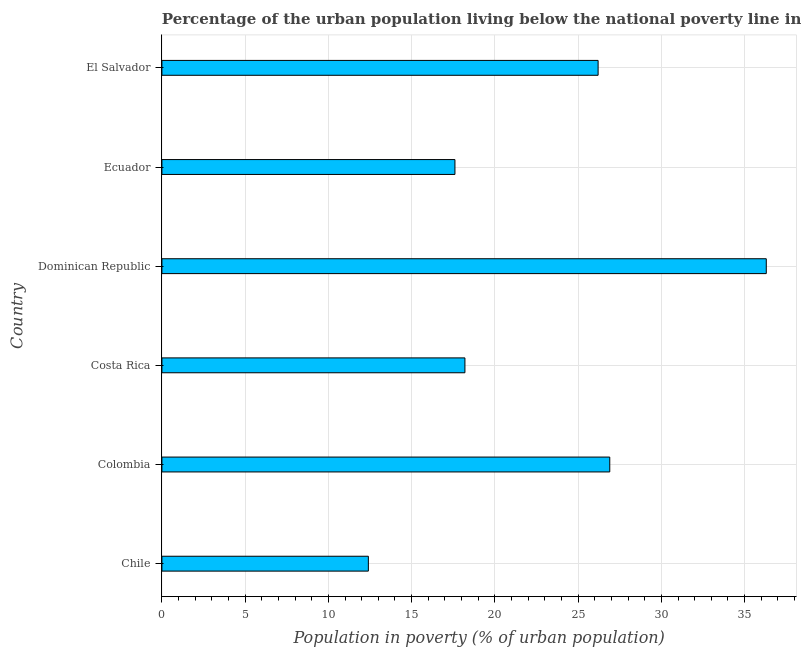What is the title of the graph?
Provide a succinct answer. Percentage of the urban population living below the national poverty line in 2013. What is the label or title of the X-axis?
Provide a short and direct response. Population in poverty (% of urban population). What is the label or title of the Y-axis?
Make the answer very short. Country. What is the percentage of urban population living below poverty line in Ecuador?
Offer a very short reply. 17.6. Across all countries, what is the maximum percentage of urban population living below poverty line?
Ensure brevity in your answer.  36.3. In which country was the percentage of urban population living below poverty line maximum?
Your answer should be compact. Dominican Republic. What is the sum of the percentage of urban population living below poverty line?
Your answer should be compact. 137.6. What is the difference between the percentage of urban population living below poverty line in Ecuador and El Salvador?
Your answer should be very brief. -8.6. What is the average percentage of urban population living below poverty line per country?
Your response must be concise. 22.93. What is the median percentage of urban population living below poverty line?
Your response must be concise. 22.2. What is the ratio of the percentage of urban population living below poverty line in Chile to that in El Salvador?
Ensure brevity in your answer.  0.47. Is the sum of the percentage of urban population living below poverty line in Dominican Republic and El Salvador greater than the maximum percentage of urban population living below poverty line across all countries?
Offer a terse response. Yes. What is the difference between the highest and the lowest percentage of urban population living below poverty line?
Your response must be concise. 23.9. Are all the bars in the graph horizontal?
Your response must be concise. Yes. How many countries are there in the graph?
Provide a succinct answer. 6. Are the values on the major ticks of X-axis written in scientific E-notation?
Keep it short and to the point. No. What is the Population in poverty (% of urban population) of Colombia?
Offer a terse response. 26.9. What is the Population in poverty (% of urban population) of Costa Rica?
Your answer should be very brief. 18.2. What is the Population in poverty (% of urban population) of Dominican Republic?
Provide a succinct answer. 36.3. What is the Population in poverty (% of urban population) of El Salvador?
Keep it short and to the point. 26.2. What is the difference between the Population in poverty (% of urban population) in Chile and Colombia?
Provide a succinct answer. -14.5. What is the difference between the Population in poverty (% of urban population) in Chile and Costa Rica?
Your answer should be very brief. -5.8. What is the difference between the Population in poverty (% of urban population) in Chile and Dominican Republic?
Offer a very short reply. -23.9. What is the difference between the Population in poverty (% of urban population) in Chile and El Salvador?
Give a very brief answer. -13.8. What is the difference between the Population in poverty (% of urban population) in Colombia and El Salvador?
Make the answer very short. 0.7. What is the difference between the Population in poverty (% of urban population) in Costa Rica and Dominican Republic?
Offer a terse response. -18.1. What is the difference between the Population in poverty (% of urban population) in Costa Rica and El Salvador?
Ensure brevity in your answer.  -8. What is the difference between the Population in poverty (% of urban population) in Dominican Republic and El Salvador?
Ensure brevity in your answer.  10.1. What is the difference between the Population in poverty (% of urban population) in Ecuador and El Salvador?
Provide a short and direct response. -8.6. What is the ratio of the Population in poverty (% of urban population) in Chile to that in Colombia?
Give a very brief answer. 0.46. What is the ratio of the Population in poverty (% of urban population) in Chile to that in Costa Rica?
Your response must be concise. 0.68. What is the ratio of the Population in poverty (% of urban population) in Chile to that in Dominican Republic?
Your answer should be compact. 0.34. What is the ratio of the Population in poverty (% of urban population) in Chile to that in Ecuador?
Provide a succinct answer. 0.7. What is the ratio of the Population in poverty (% of urban population) in Chile to that in El Salvador?
Make the answer very short. 0.47. What is the ratio of the Population in poverty (% of urban population) in Colombia to that in Costa Rica?
Give a very brief answer. 1.48. What is the ratio of the Population in poverty (% of urban population) in Colombia to that in Dominican Republic?
Provide a short and direct response. 0.74. What is the ratio of the Population in poverty (% of urban population) in Colombia to that in Ecuador?
Provide a succinct answer. 1.53. What is the ratio of the Population in poverty (% of urban population) in Costa Rica to that in Dominican Republic?
Your response must be concise. 0.5. What is the ratio of the Population in poverty (% of urban population) in Costa Rica to that in Ecuador?
Provide a succinct answer. 1.03. What is the ratio of the Population in poverty (% of urban population) in Costa Rica to that in El Salvador?
Keep it short and to the point. 0.69. What is the ratio of the Population in poverty (% of urban population) in Dominican Republic to that in Ecuador?
Offer a terse response. 2.06. What is the ratio of the Population in poverty (% of urban population) in Dominican Republic to that in El Salvador?
Your answer should be compact. 1.39. What is the ratio of the Population in poverty (% of urban population) in Ecuador to that in El Salvador?
Provide a short and direct response. 0.67. 